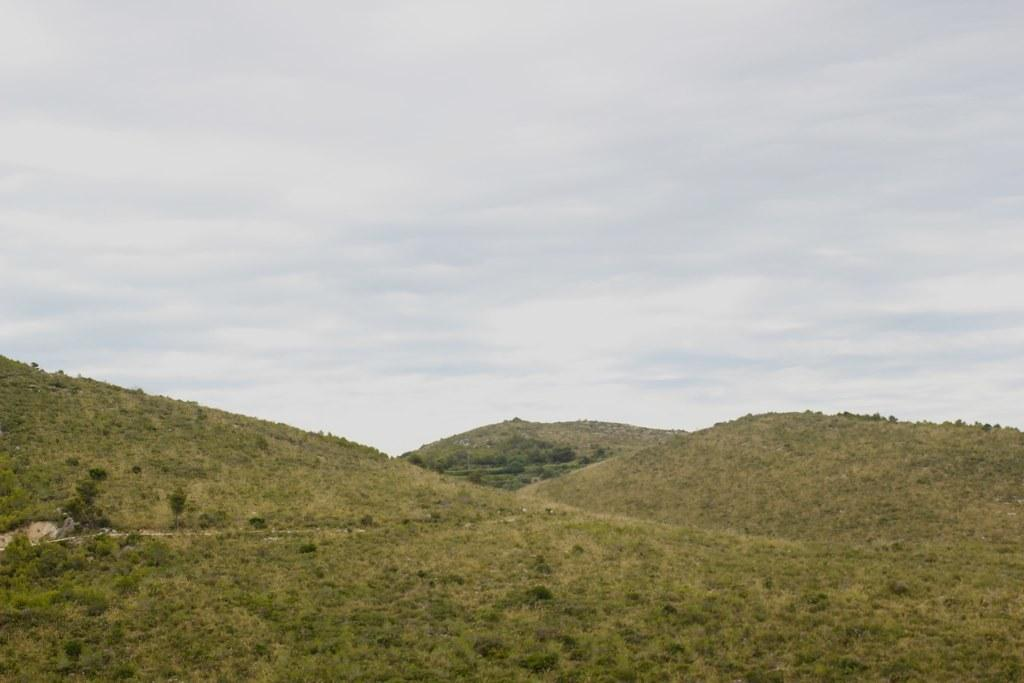What type of surface is on the ground in the image? There is grass on the ground in the image. What other types of vegetation can be seen in the image? There are plants and trees in the image. What is visible in the background of the image? Greenery is visible in the background of the image. How would you describe the sky in the image? The sky is cloudy in the image. What type of bells can be heard ringing in the image? There are no bells present in the image, and therefore no sound can be heard. 